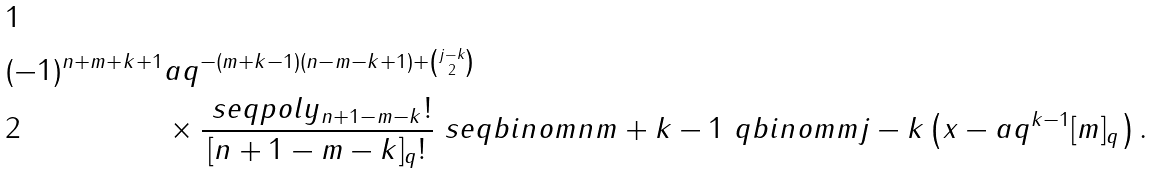<formula> <loc_0><loc_0><loc_500><loc_500>( - 1 ) ^ { { n } + { m } + { k } + 1 } & { a } q ^ { - ( { m } + { k } - 1 ) ( { n } - { m } - { k } + 1 ) + \binom { j - { k } } 2 } \\ & \times \frac { \ s e q p o l y _ { { n } + 1 - { m } - { k } } ! } { [ { n } + 1 - { m } - { k } ] _ { q } ! } \ s e q b i n o m { n } { { m } + { k } - 1 } \ q b i n o m { m } { j - { k } } \left ( { x } - { a } q ^ { { k } - 1 } [ { m } ] _ { q } \right ) .</formula> 